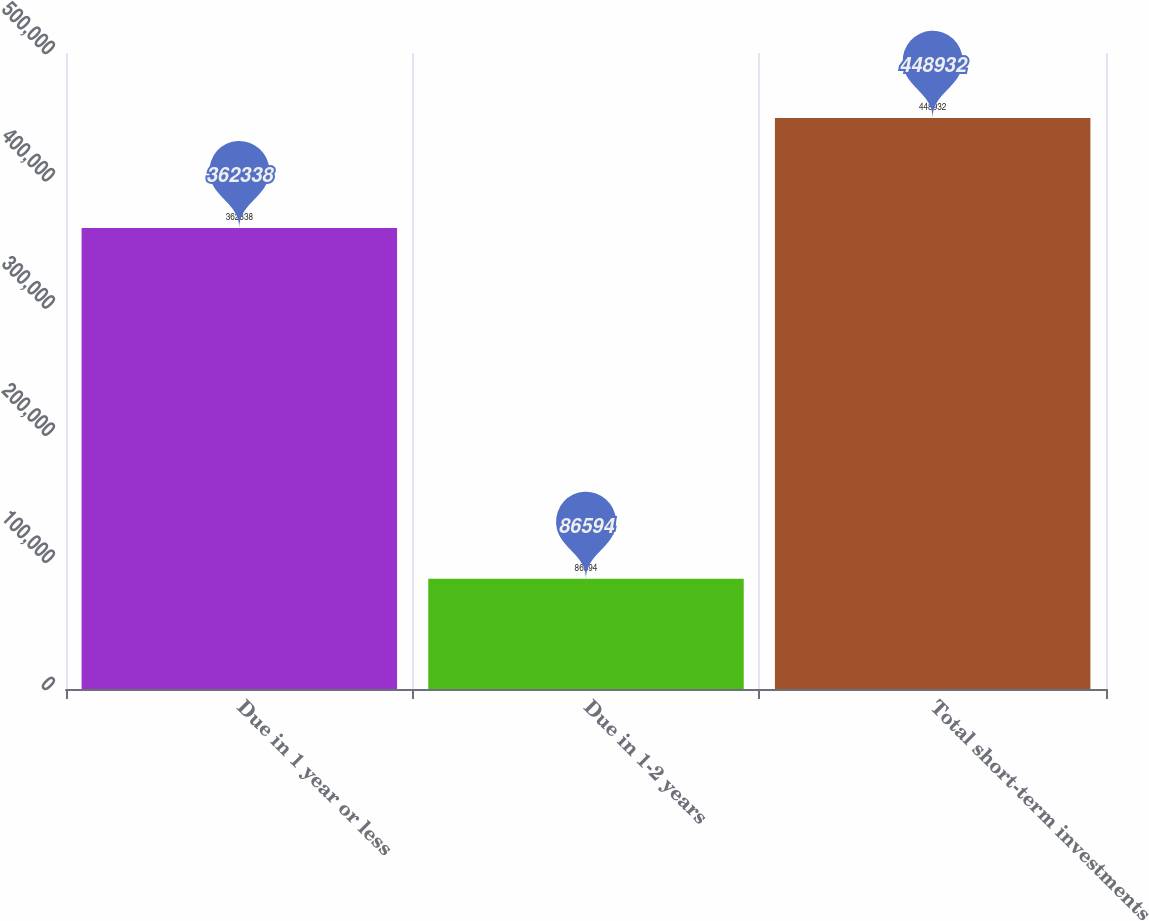Convert chart to OTSL. <chart><loc_0><loc_0><loc_500><loc_500><bar_chart><fcel>Due in 1 year or less<fcel>Due in 1-2 years<fcel>Total short-term investments<nl><fcel>362338<fcel>86594<fcel>448932<nl></chart> 